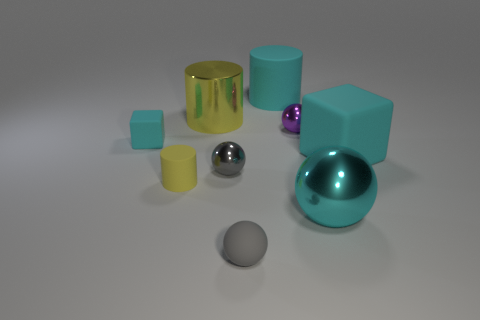Subtract all matte cylinders. How many cylinders are left? 1 Subtract all cyan balls. How many balls are left? 3 Subtract 0 yellow spheres. How many objects are left? 9 Subtract all cylinders. How many objects are left? 6 Subtract 4 balls. How many balls are left? 0 Subtract all green blocks. Subtract all yellow cylinders. How many blocks are left? 2 Subtract all purple cubes. How many cyan balls are left? 1 Subtract all brown metallic spheres. Subtract all small gray matte spheres. How many objects are left? 8 Add 4 tiny purple metallic spheres. How many tiny purple metallic spheres are left? 5 Add 5 large matte cylinders. How many large matte cylinders exist? 6 